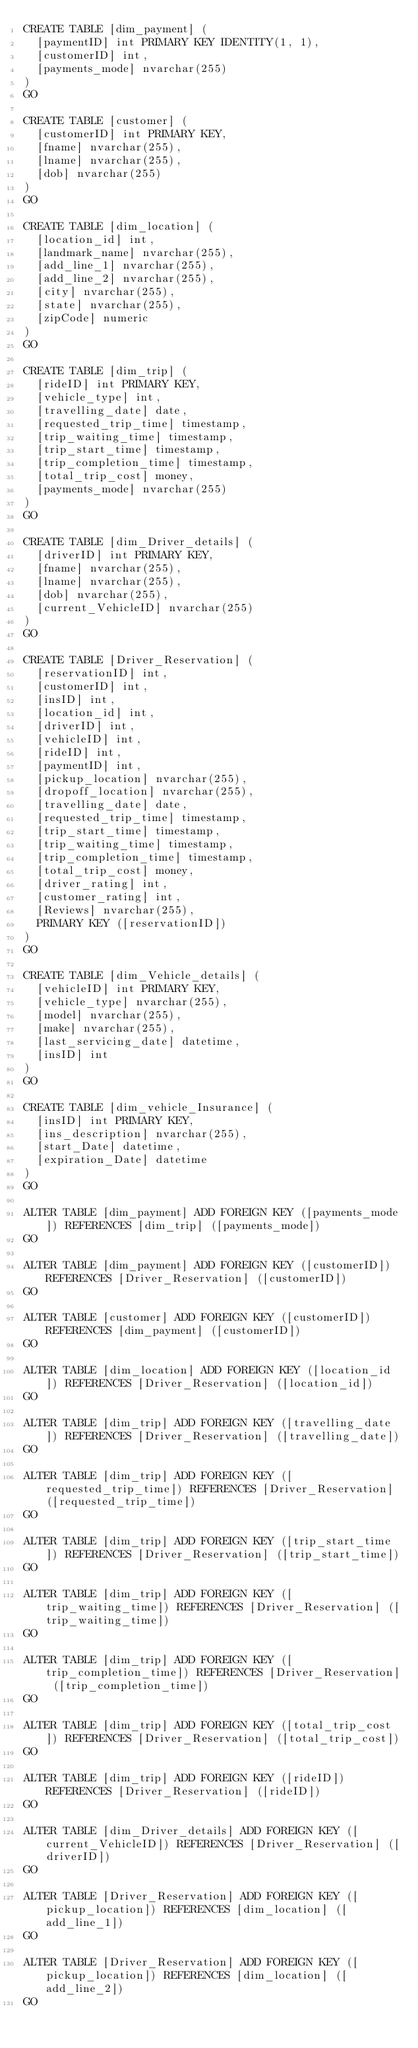Convert code to text. <code><loc_0><loc_0><loc_500><loc_500><_SQL_>CREATE TABLE [dim_payment] (
  [paymentID] int PRIMARY KEY IDENTITY(1, 1),
  [customerID] int,
  [payments_mode] nvarchar(255)
)
GO

CREATE TABLE [customer] (
  [customerID] int PRIMARY KEY,
  [fname] nvarchar(255),
  [lname] nvarchar(255),
  [dob] nvarchar(255)
)
GO

CREATE TABLE [dim_location] (
  [location_id] int,
  [landmark_name] nvarchar(255),
  [add_line_1] nvarchar(255),
  [add_line_2] nvarchar(255),
  [city] nvarchar(255),
  [state] nvarchar(255),
  [zipCode] numeric
)
GO

CREATE TABLE [dim_trip] (
  [rideID] int PRIMARY KEY,
  [vehicle_type] int,
  [travelling_date] date,
  [requested_trip_time] timestamp,
  [trip_waiting_time] timestamp,
  [trip_start_time] timestamp,
  [trip_completion_time] timestamp,
  [total_trip_cost] money,
  [payments_mode] nvarchar(255)
)
GO

CREATE TABLE [dim_Driver_details] (
  [driverID] int PRIMARY KEY,
  [fname] nvarchar(255),
  [lname] nvarchar(255),
  [dob] nvarchar(255),
  [current_VehicleID] nvarchar(255)
)
GO

CREATE TABLE [Driver_Reservation] (
  [reservationID] int,
  [customerID] int,
  [insID] int,
  [location_id] int,
  [driverID] int,
  [vehicleID] int,
  [rideID] int,
  [paymentID] int,
  [pickup_location] nvarchar(255),
  [dropoff_location] nvarchar(255),
  [travelling_date] date,
  [requested_trip_time] timestamp,
  [trip_start_time] timestamp,
  [trip_waiting_time] timestamp,
  [trip_completion_time] timestamp,
  [total_trip_cost] money,
  [driver_rating] int,
  [customer_rating] int,
  [Reviews] nvarchar(255),
  PRIMARY KEY ([reservationID])
)
GO

CREATE TABLE [dim_Vehicle_details] (
  [vehicleID] int PRIMARY KEY,
  [vehicle_type] nvarchar(255),
  [model] nvarchar(255),
  [make] nvarchar(255),
  [last_servicing_date] datetime,
  [insID] int
)
GO

CREATE TABLE [dim_vehicle_Insurance] (
  [insID] int PRIMARY KEY,
  [ins_description] nvarchar(255),
  [start_Date] datetime,
  [expiration_Date] datetime
)
GO

ALTER TABLE [dim_payment] ADD FOREIGN KEY ([payments_mode]) REFERENCES [dim_trip] ([payments_mode])
GO

ALTER TABLE [dim_payment] ADD FOREIGN KEY ([customerID]) REFERENCES [Driver_Reservation] ([customerID])
GO

ALTER TABLE [customer] ADD FOREIGN KEY ([customerID]) REFERENCES [dim_payment] ([customerID])
GO

ALTER TABLE [dim_location] ADD FOREIGN KEY ([location_id]) REFERENCES [Driver_Reservation] ([location_id])
GO

ALTER TABLE [dim_trip] ADD FOREIGN KEY ([travelling_date]) REFERENCES [Driver_Reservation] ([travelling_date])
GO

ALTER TABLE [dim_trip] ADD FOREIGN KEY ([requested_trip_time]) REFERENCES [Driver_Reservation] ([requested_trip_time])
GO

ALTER TABLE [dim_trip] ADD FOREIGN KEY ([trip_start_time]) REFERENCES [Driver_Reservation] ([trip_start_time])
GO

ALTER TABLE [dim_trip] ADD FOREIGN KEY ([trip_waiting_time]) REFERENCES [Driver_Reservation] ([trip_waiting_time])
GO

ALTER TABLE [dim_trip] ADD FOREIGN KEY ([trip_completion_time]) REFERENCES [Driver_Reservation] ([trip_completion_time])
GO

ALTER TABLE [dim_trip] ADD FOREIGN KEY ([total_trip_cost]) REFERENCES [Driver_Reservation] ([total_trip_cost])
GO

ALTER TABLE [dim_trip] ADD FOREIGN KEY ([rideID]) REFERENCES [Driver_Reservation] ([rideID])
GO

ALTER TABLE [dim_Driver_details] ADD FOREIGN KEY ([current_VehicleID]) REFERENCES [Driver_Reservation] ([driverID])
GO

ALTER TABLE [Driver_Reservation] ADD FOREIGN KEY ([pickup_location]) REFERENCES [dim_location] ([add_line_1])
GO

ALTER TABLE [Driver_Reservation] ADD FOREIGN KEY ([pickup_location]) REFERENCES [dim_location] ([add_line_2])
GO
</code> 